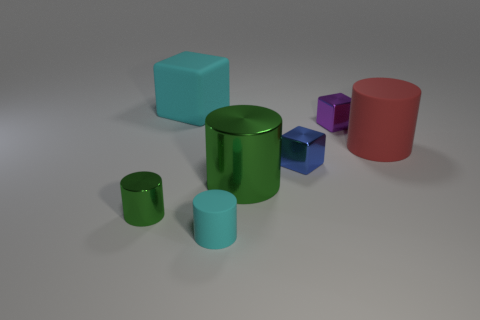How many rubber objects are either big green cubes or green cylinders?
Offer a very short reply. 0. There is a shiny thing to the left of the big green object; what number of metallic cubes are to the right of it?
Give a very brief answer. 2. How many cyan cylinders have the same material as the cyan cube?
Give a very brief answer. 1. How many big things are either shiny cylinders or red cylinders?
Provide a short and direct response. 2. The small thing that is to the right of the small cyan rubber object and in front of the red rubber thing has what shape?
Keep it short and to the point. Cube. Are the big green object and the large cyan block made of the same material?
Your answer should be very brief. No. There is a matte cylinder that is the same size as the purple cube; what is its color?
Keep it short and to the point. Cyan. There is a big thing that is both in front of the big matte cube and behind the big green metal cylinder; what is its color?
Make the answer very short. Red. What is the size of the other cylinder that is the same color as the small metallic cylinder?
Keep it short and to the point. Large. What is the shape of the other thing that is the same color as the big shiny thing?
Make the answer very short. Cylinder. 